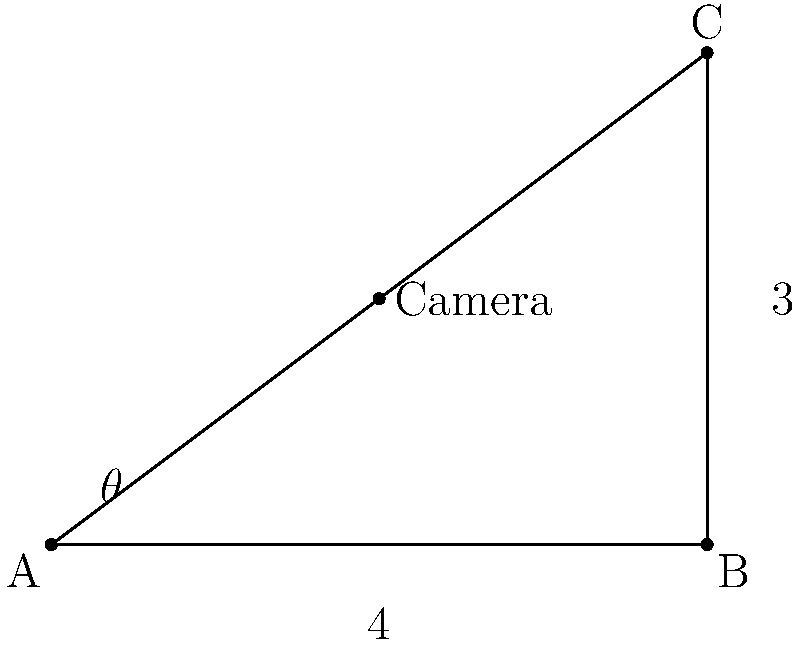As a film critic analyzing camera techniques, you're examining a scene where the camera is positioned inside a right-angled triangle set. The camera is placed along the height of the triangle, which forms the angle $\theta$ with the base. If the base of the triangle is 4 units and the height is 3 units, at what angle $\theta$ should the camera be positioned to maximize the visible area of the set? Use calculus to determine the optimal angle. Let's approach this step-by-step:

1) The visible area is composed of two triangles. Let's call the distance from A to the camera point x.

2) The areas of these triangles are:
   $$A_1 = \frac{1}{2} \cdot x \cdot 3$$
   $$A_2 = \frac{1}{2} \cdot (4-x) \cdot 3$$

3) The total visible area is:
   $$A = A_1 + A_2 = \frac{1}{2} \cdot x \cdot 3 + \frac{1}{2} \cdot (4-x) \cdot 3 = \frac{3x}{2} + 6 - \frac{3x}{2} = 6$$

4) This result shows that the visible area is constant regardless of the camera position. However, we need to maximize the product of these areas to ensure the best overall view:

   $$f(x) = A_1 \cdot A_2 = (\frac{3x}{2}) \cdot (6 - \frac{3x}{2}) = \frac{9x}{2} - \frac{9x^2}{4}$$

5) To find the maximum, we differentiate and set to zero:
   $$f'(x) = \frac{9}{2} - \frac{9x}{2} = 0$$

6) Solving this:
   $$\frac{9x}{2} = \frac{9}{2}$$
   $$x = 1$$

7) This means the camera should be positioned 1 unit from point A.

8) To find $\theta$, we use:
   $$\tan(\theta) = \frac{3}{4}$$
   $$\theta = \arctan(\frac{3}{4}) \approx 36.87°$$
Answer: $36.87°$ 